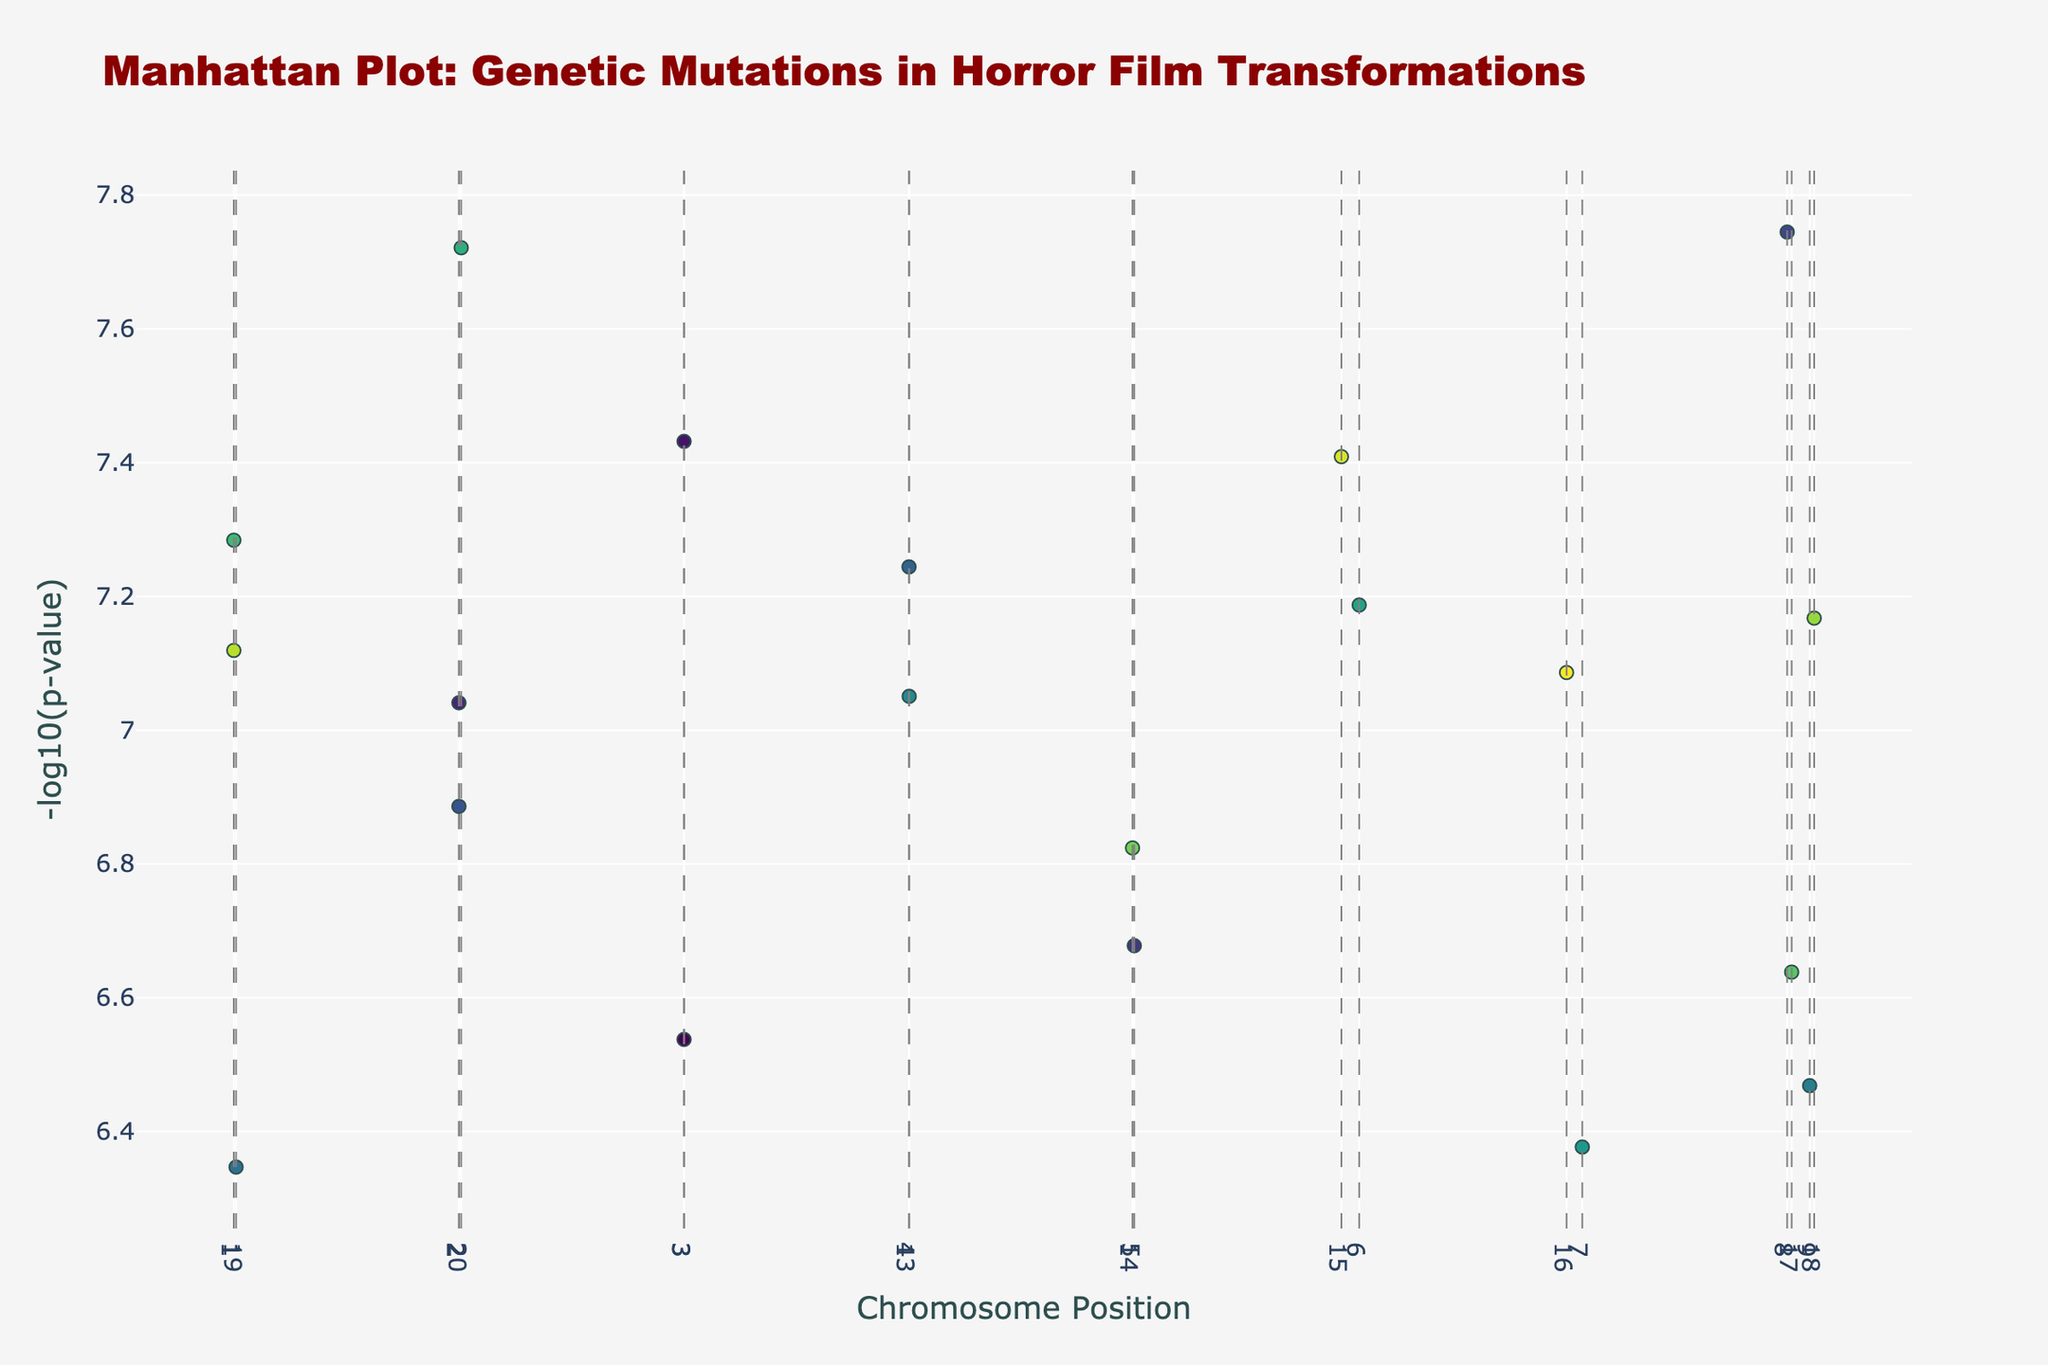How many chromosomes are represented in the plot? The x-axis indicates multiple chromosomes, each marked by unique positions. By counting the unique chromosomes listed, we see there are 20.
Answer: 20 Which gene is associated with the transformation of skin? By examining the hover text or by noting specific point locations, the gene associated with 'Skin' is TP53.
Answer: TP53 What is the title of the plot? By looking at the top of the figure, the title reads 'Manhattan Plot: Genetic Mutations in Horror Film Transformations'.
Answer: Manhattan Plot: Genetic Mutations in Horror Film Transformations How is the -log10(p-value) axis labeled? The y-axis label can be seen to read '-log10(p-value)', indicating how statistical significance is visualized.
Answer: -log10(p-value) Which body part had the mutation with the lowest p-value? By comparing the -log10(p-value) heights of the points, the highest point, indicating the lowest p-value, corresponds to the body part 'Facial_Features' associated with the gene PAX6.
Answer: Facial_Features How many data points have a -log10(p-value) greater than 7? By visually identifying the points surpassing the horizontal grid line at 7 on the y-axis, there are 2 points: TP53 (Skin) and PAX6 (Facial_Features).
Answer: 2 Which gene associated with 'Hair' has the highest chromosome position? By locating the gene associated with 'Hair' (BRCA1) at position 23456789 on chromosome 2, it can be identified as having the highest chromosome position.
Answer: BRCA1 Which body parts are affected by mutations on chromosome 7? By noting the positions on the x-axis belonging to chromosome 7, the corresponding genes and body parts in the hover text indicate 'Pigmentation' (PMEL).
Answer: Pigmentation (PMEL) How are different body parts distinguished visually in the plot? Each point represents a different body part and is color-coded. They are also distinguished by different positions on the plot.
Answer: By colors and positions What can be inferred about the mutation linked to 'Wings'? The point for 'Wings' associated with gene LAMA3 is noticeable due to its -log10(p-value) value, suggesting it has moderate significance visually represented by its position.
Answer: Moderate significance 